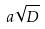<formula> <loc_0><loc_0><loc_500><loc_500>a \sqrt { D }</formula> 